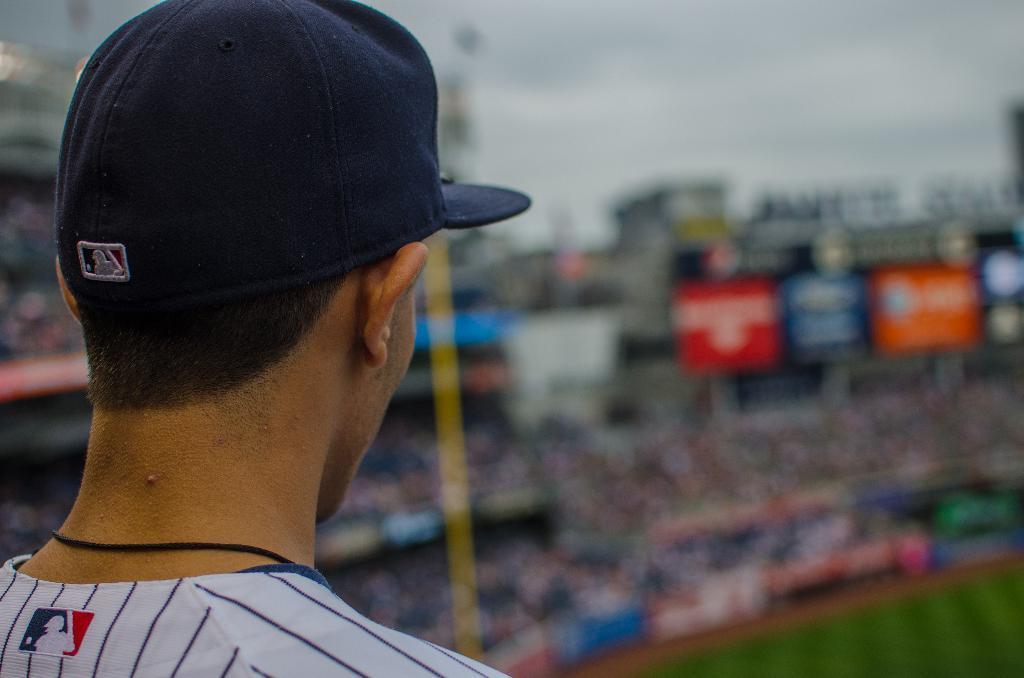In one or two sentences, can you explain what this image depicts? In the image on the left we can see one person standing and wearing black color cap. In the background we can see sky,clouds,stadium,banners,sign boards etc. 